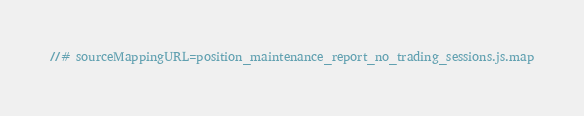<code> <loc_0><loc_0><loc_500><loc_500><_JavaScript_>//# sourceMappingURL=position_maintenance_report_no_trading_sessions.js.map</code> 